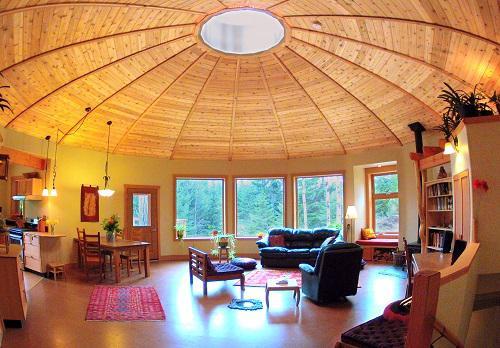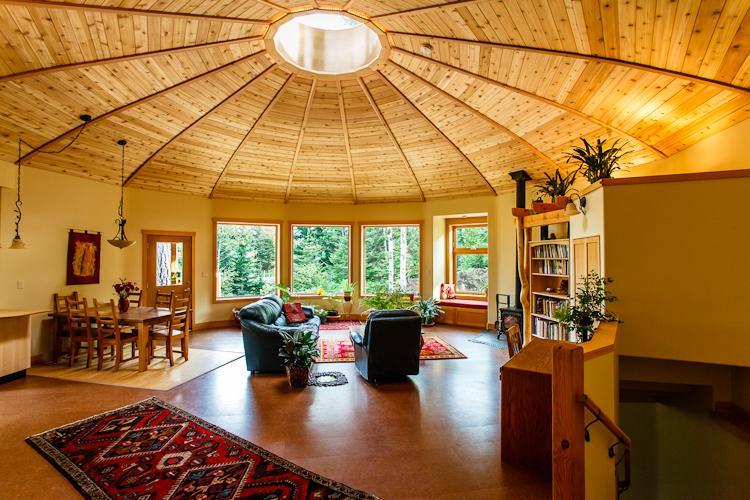The first image is the image on the left, the second image is the image on the right. Given the left and right images, does the statement "At least one house has no visible windows." hold true? Answer yes or no. No. 